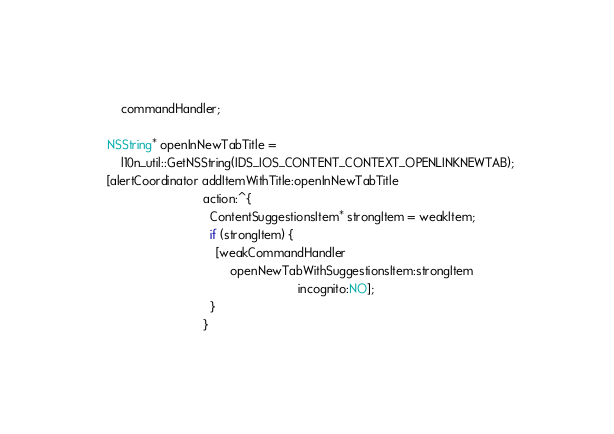Convert code to text. <code><loc_0><loc_0><loc_500><loc_500><_ObjectiveC_>      commandHandler;

  NSString* openInNewTabTitle =
      l10n_util::GetNSString(IDS_IOS_CONTENT_CONTEXT_OPENLINKNEWTAB);
  [alertCoordinator addItemWithTitle:openInNewTabTitle
                              action:^{
                                ContentSuggestionsItem* strongItem = weakItem;
                                if (strongItem) {
                                  [weakCommandHandler
                                      openNewTabWithSuggestionsItem:strongItem
                                                          incognito:NO];
                                }
                              }</code> 